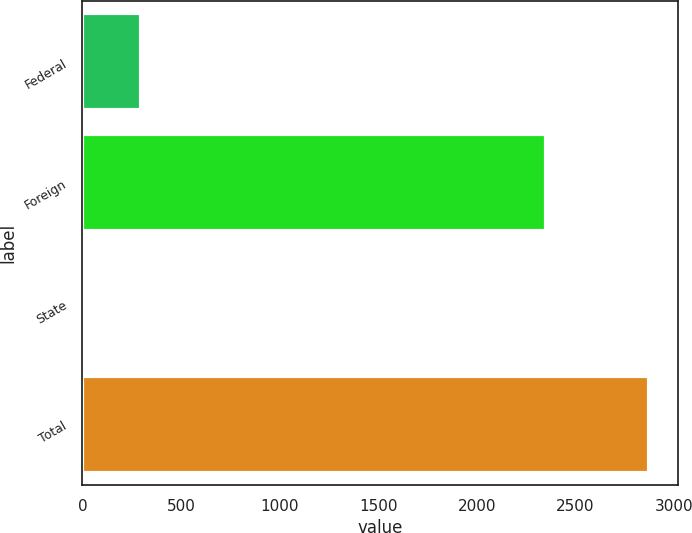Convert chart. <chart><loc_0><loc_0><loc_500><loc_500><bar_chart><fcel>Federal<fcel>Foreign<fcel>State<fcel>Total<nl><fcel>296.6<fcel>2349<fcel>10<fcel>2876<nl></chart> 